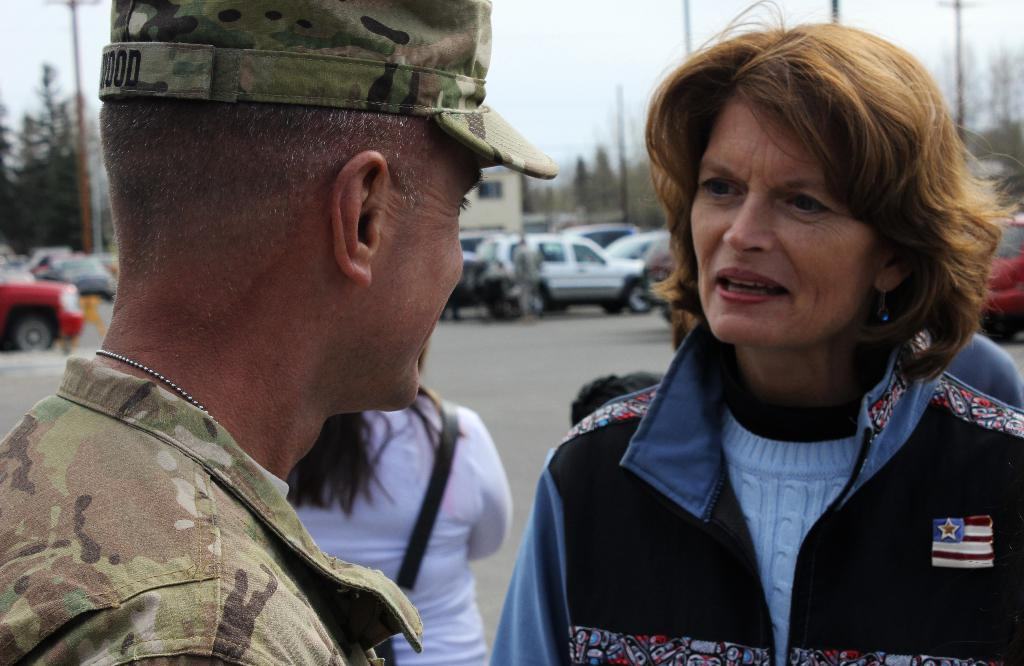Who or what is present in the image? There are people in the image. What else can be seen in the image besides the people? There are vehicles on the road in the image. What can be seen in the background of the image? There are trees, poles, and the sky visible in the background of the image. How many fish can be seen swimming in the image? There are no fish present in the image. What is the wealth of the people in the image? The wealth of the people in the image cannot be determined from the image itself. 